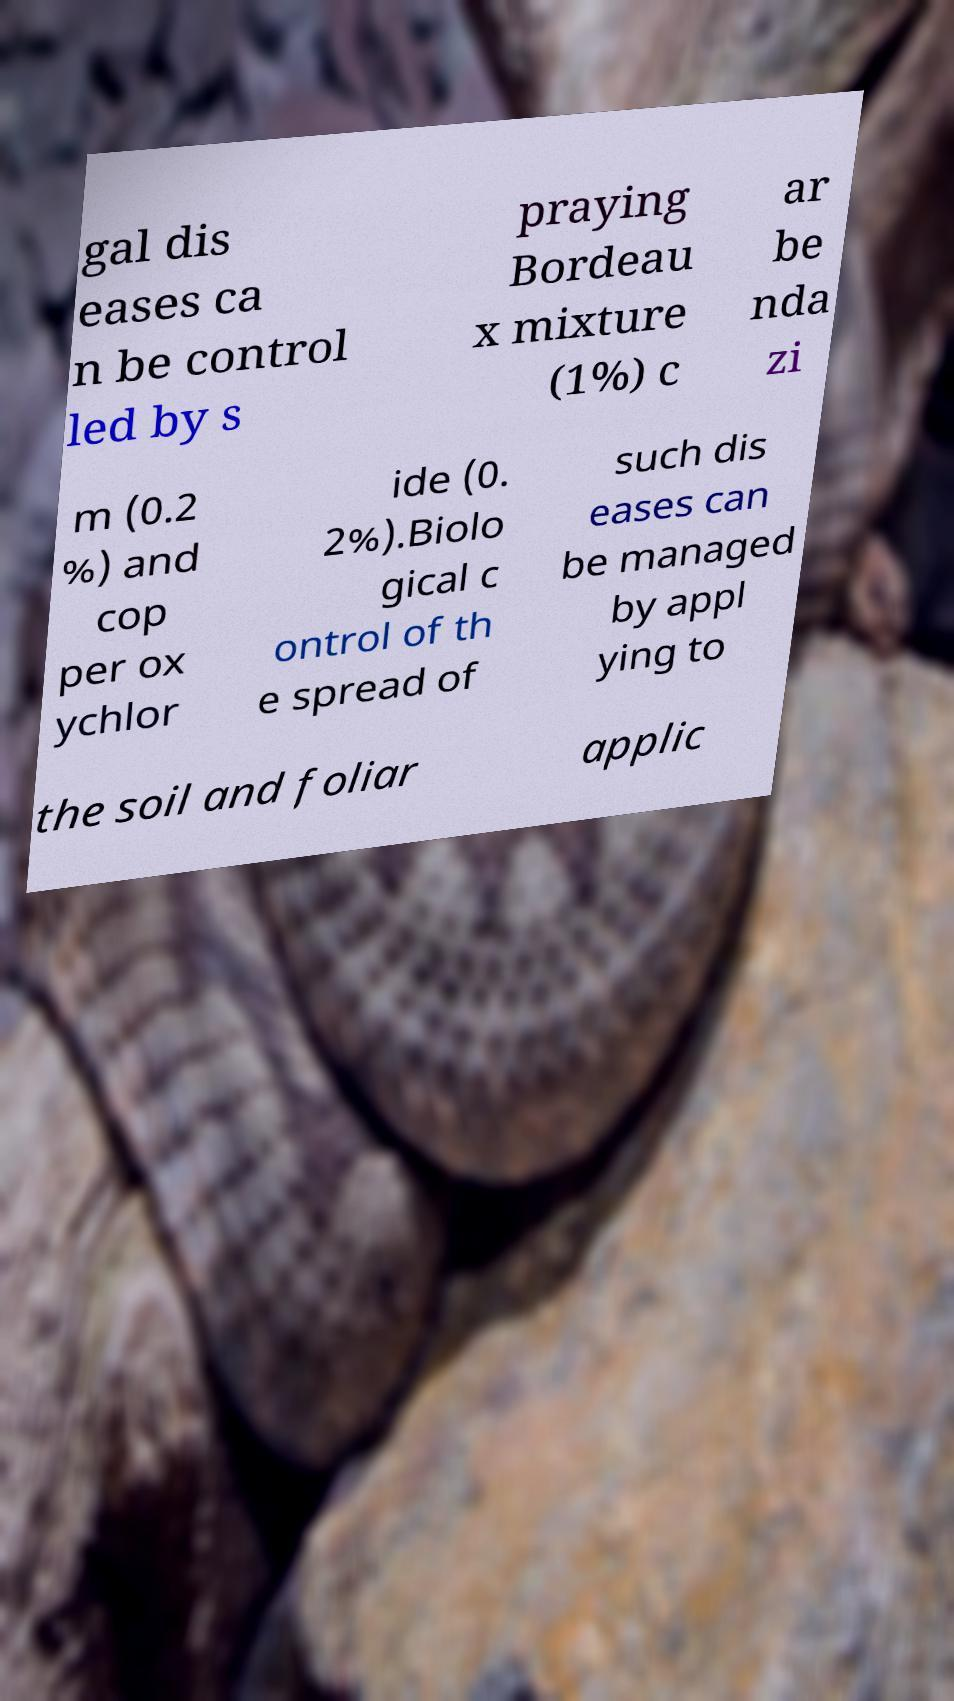I need the written content from this picture converted into text. Can you do that? gal dis eases ca n be control led by s praying Bordeau x mixture (1%) c ar be nda zi m (0.2 %) and cop per ox ychlor ide (0. 2%).Biolo gical c ontrol of th e spread of such dis eases can be managed by appl ying to the soil and foliar applic 